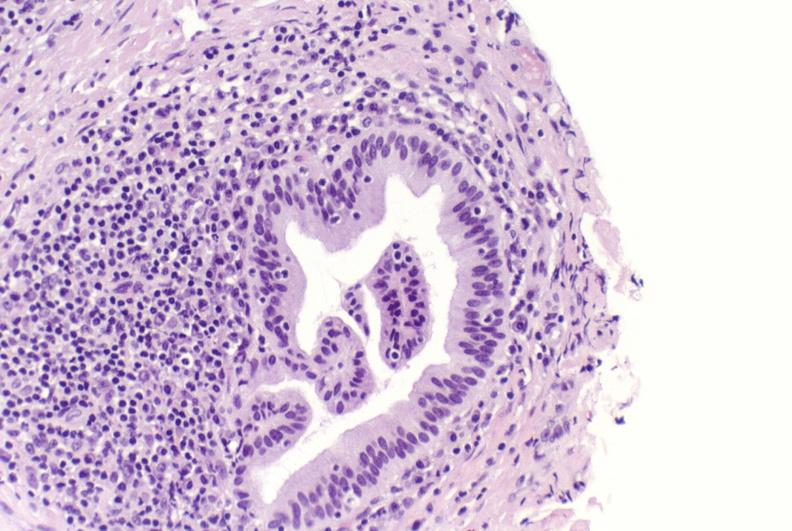what does this image show?
Answer the question using a single word or phrase. Primary biliary cirrhosis 